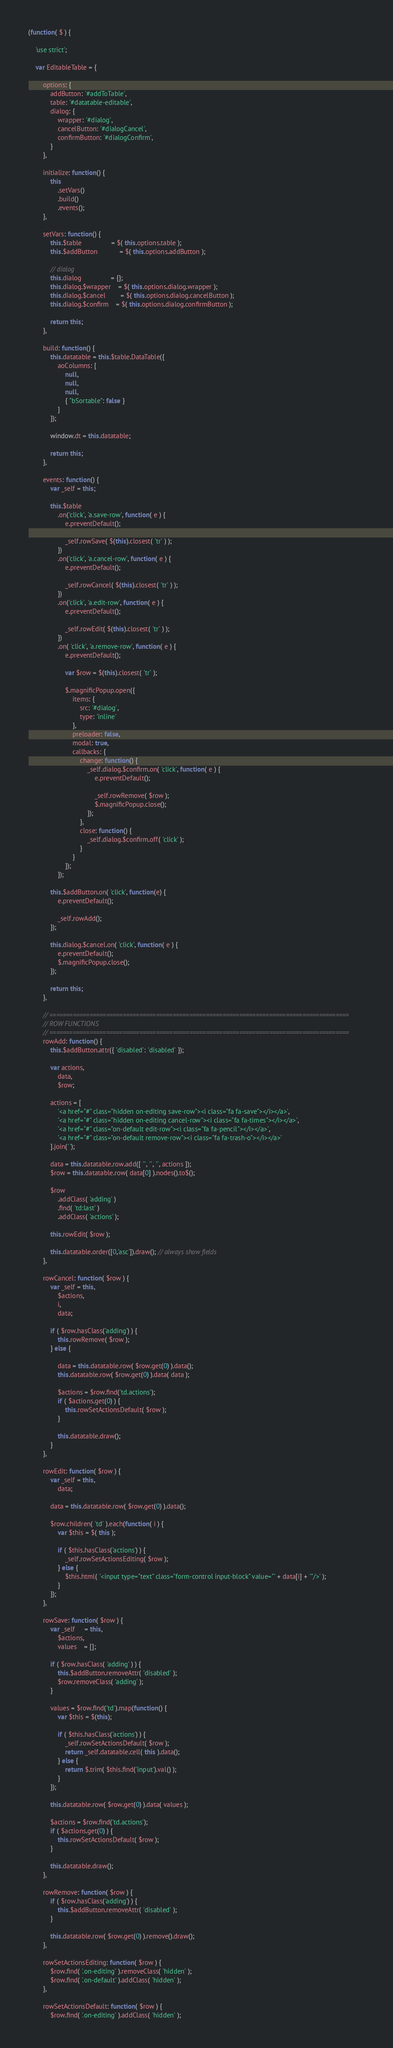Convert code to text. <code><loc_0><loc_0><loc_500><loc_500><_JavaScript_>

(function( $ ) {

	'use strict';

	var EditableTable = {

		options: {
			addButton: '#addToTable',
			table: '#datatable-editable',
			dialog: {
				wrapper: '#dialog',
				cancelButton: '#dialogCancel',
				confirmButton: '#dialogConfirm',
			}
		},

		initialize: function() {
			this
				.setVars()
				.build()
				.events();
		},

		setVars: function() {
			this.$table				= $( this.options.table );
			this.$addButton			= $( this.options.addButton );

			// dialog
			this.dialog				= {};
			this.dialog.$wrapper	= $( this.options.dialog.wrapper );
			this.dialog.$cancel		= $( this.options.dialog.cancelButton );
			this.dialog.$confirm	= $( this.options.dialog.confirmButton );

			return this;
		},

		build: function() {
			this.datatable = this.$table.DataTable({
				aoColumns: [
					null,
					null,
					null,
					{ "bSortable": false }
				]
			});

			window.dt = this.datatable;

			return this;
		},

		events: function() {
			var _self = this;

			this.$table
				.on('click', 'a.save-row', function( e ) {
					e.preventDefault();

					_self.rowSave( $(this).closest( 'tr' ) );
				})
				.on('click', 'a.cancel-row', function( e ) {
					e.preventDefault();

					_self.rowCancel( $(this).closest( 'tr' ) );
				})
				.on('click', 'a.edit-row', function( e ) {
					e.preventDefault();

					_self.rowEdit( $(this).closest( 'tr' ) );
				})
				.on( 'click', 'a.remove-row', function( e ) {
					e.preventDefault();

					var $row = $(this).closest( 'tr' );

					$.magnificPopup.open({
						items: {
							src: '#dialog',
							type: 'inline'
						},
						preloader: false,
						modal: true,
						callbacks: {
							change: function() {
								_self.dialog.$confirm.on( 'click', function( e ) {
									e.preventDefault();

									_self.rowRemove( $row );
									$.magnificPopup.close();
								});
							},
							close: function() {
								_self.dialog.$confirm.off( 'click' );
							}
						}
					});
				});

			this.$addButton.on( 'click', function(e) {
				e.preventDefault();

				_self.rowAdd();
			});

			this.dialog.$cancel.on( 'click', function( e ) {
				e.preventDefault();
				$.magnificPopup.close();
			});

			return this;
		},

		// ==========================================================================================
		// ROW FUNCTIONS
		// ==========================================================================================
		rowAdd: function() {
			this.$addButton.attr({ 'disabled': 'disabled' });

			var actions,
				data,
				$row;

			actions = [
				'<a href="#" class="hidden on-editing save-row"><i class="fa fa-save"></i></a>',
				'<a href="#" class="hidden on-editing cancel-row"><i class="fa fa-times"></i></a>',
				'<a href="#" class="on-default edit-row"><i class="fa fa-pencil"></i></a>',
				'<a href="#" class="on-default remove-row"><i class="fa fa-trash-o"></i></a>'
			].join(' ');

			data = this.datatable.row.add([ '', '', '', actions ]);
			$row = this.datatable.row( data[0] ).nodes().to$();

			$row
				.addClass( 'adding' )
				.find( 'td:last' )
				.addClass( 'actions' );

			this.rowEdit( $row );

			this.datatable.order([0,'asc']).draw(); // always show fields
		},

		rowCancel: function( $row ) {
			var _self = this,
				$actions,
				i,
				data;

			if ( $row.hasClass('adding') ) {
				this.rowRemove( $row );
			} else {

				data = this.datatable.row( $row.get(0) ).data();
				this.datatable.row( $row.get(0) ).data( data );

				$actions = $row.find('td.actions');
				if ( $actions.get(0) ) {
					this.rowSetActionsDefault( $row );
				}

				this.datatable.draw();
			}
		},

		rowEdit: function( $row ) {
			var _self = this,
				data;

			data = this.datatable.row( $row.get(0) ).data();

			$row.children( 'td' ).each(function( i ) {
				var $this = $( this );

				if ( $this.hasClass('actions') ) {
					_self.rowSetActionsEditing( $row );
				} else {
					$this.html( '<input type="text" class="form-control input-block" value="' + data[i] + '"/>' );
				}
			});
		},

		rowSave: function( $row ) {
			var _self     = this,
				$actions,
				values    = [];

			if ( $row.hasClass( 'adding' ) ) {
				this.$addButton.removeAttr( 'disabled' );
				$row.removeClass( 'adding' );
			}

			values = $row.find('td').map(function() {
				var $this = $(this);

				if ( $this.hasClass('actions') ) {
					_self.rowSetActionsDefault( $row );
					return _self.datatable.cell( this ).data();
				} else {
					return $.trim( $this.find('input').val() );
				}
			});

			this.datatable.row( $row.get(0) ).data( values );

			$actions = $row.find('td.actions');
			if ( $actions.get(0) ) {
				this.rowSetActionsDefault( $row );
			}

			this.datatable.draw();
		},

		rowRemove: function( $row ) {
			if ( $row.hasClass('adding') ) {
				this.$addButton.removeAttr( 'disabled' );
			}

			this.datatable.row( $row.get(0) ).remove().draw();
		},

		rowSetActionsEditing: function( $row ) {
			$row.find( '.on-editing' ).removeClass( 'hidden' );
			$row.find( '.on-default' ).addClass( 'hidden' );
		},

		rowSetActionsDefault: function( $row ) {
			$row.find( '.on-editing' ).addClass( 'hidden' );</code> 